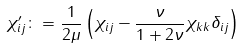<formula> <loc_0><loc_0><loc_500><loc_500>\chi ^ { \prime } _ { i j } \colon = \frac { 1 } { 2 \mu } \left ( \chi _ { i j } - \frac { \nu } { 1 + 2 \nu } \chi _ { k k } \delta _ { i j } \right )</formula> 